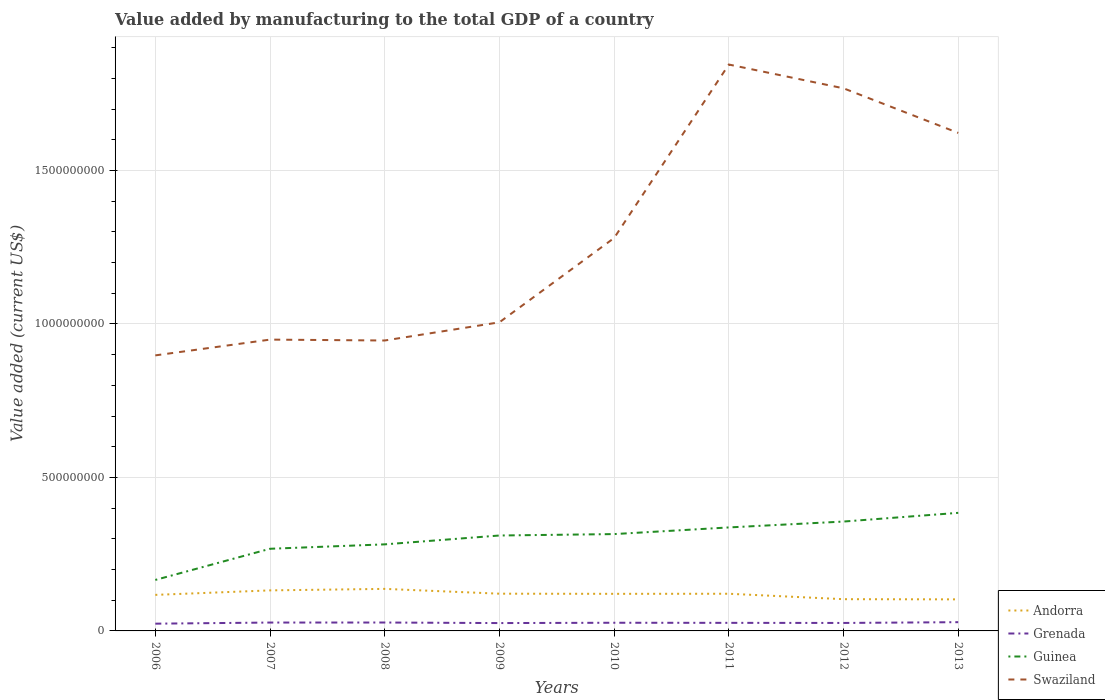Does the line corresponding to Swaziland intersect with the line corresponding to Andorra?
Your answer should be very brief. No. Across all years, what is the maximum value added by manufacturing to the total GDP in Swaziland?
Ensure brevity in your answer.  8.98e+08. What is the total value added by manufacturing to the total GDP in Swaziland in the graph?
Provide a short and direct response. -6.17e+08. What is the difference between the highest and the second highest value added by manufacturing to the total GDP in Grenada?
Ensure brevity in your answer.  4.85e+06. How many years are there in the graph?
Provide a short and direct response. 8. Does the graph contain any zero values?
Provide a succinct answer. No. How many legend labels are there?
Make the answer very short. 4. What is the title of the graph?
Your answer should be compact. Value added by manufacturing to the total GDP of a country. Does "Azerbaijan" appear as one of the legend labels in the graph?
Your answer should be very brief. No. What is the label or title of the X-axis?
Your answer should be compact. Years. What is the label or title of the Y-axis?
Offer a terse response. Value added (current US$). What is the Value added (current US$) in Andorra in 2006?
Make the answer very short. 1.17e+08. What is the Value added (current US$) in Grenada in 2006?
Offer a very short reply. 2.36e+07. What is the Value added (current US$) of Guinea in 2006?
Give a very brief answer. 1.66e+08. What is the Value added (current US$) of Swaziland in 2006?
Ensure brevity in your answer.  8.98e+08. What is the Value added (current US$) of Andorra in 2007?
Ensure brevity in your answer.  1.32e+08. What is the Value added (current US$) of Grenada in 2007?
Provide a short and direct response. 2.73e+07. What is the Value added (current US$) of Guinea in 2007?
Provide a short and direct response. 2.68e+08. What is the Value added (current US$) of Swaziland in 2007?
Provide a succinct answer. 9.49e+08. What is the Value added (current US$) in Andorra in 2008?
Provide a succinct answer. 1.37e+08. What is the Value added (current US$) of Grenada in 2008?
Provide a succinct answer. 2.74e+07. What is the Value added (current US$) in Guinea in 2008?
Offer a very short reply. 2.82e+08. What is the Value added (current US$) in Swaziland in 2008?
Give a very brief answer. 9.46e+08. What is the Value added (current US$) in Andorra in 2009?
Give a very brief answer. 1.21e+08. What is the Value added (current US$) in Grenada in 2009?
Your answer should be very brief. 2.56e+07. What is the Value added (current US$) of Guinea in 2009?
Provide a short and direct response. 3.11e+08. What is the Value added (current US$) in Swaziland in 2009?
Keep it short and to the point. 1.01e+09. What is the Value added (current US$) of Andorra in 2010?
Ensure brevity in your answer.  1.21e+08. What is the Value added (current US$) in Grenada in 2010?
Your answer should be compact. 2.66e+07. What is the Value added (current US$) in Guinea in 2010?
Provide a succinct answer. 3.15e+08. What is the Value added (current US$) of Swaziland in 2010?
Offer a very short reply. 1.28e+09. What is the Value added (current US$) of Andorra in 2011?
Offer a terse response. 1.21e+08. What is the Value added (current US$) of Grenada in 2011?
Offer a terse response. 2.63e+07. What is the Value added (current US$) of Guinea in 2011?
Make the answer very short. 3.37e+08. What is the Value added (current US$) of Swaziland in 2011?
Ensure brevity in your answer.  1.85e+09. What is the Value added (current US$) of Andorra in 2012?
Your answer should be very brief. 1.03e+08. What is the Value added (current US$) in Grenada in 2012?
Provide a short and direct response. 2.60e+07. What is the Value added (current US$) of Guinea in 2012?
Offer a terse response. 3.56e+08. What is the Value added (current US$) in Swaziland in 2012?
Provide a short and direct response. 1.77e+09. What is the Value added (current US$) of Andorra in 2013?
Provide a succinct answer. 1.03e+08. What is the Value added (current US$) of Grenada in 2013?
Provide a short and direct response. 2.85e+07. What is the Value added (current US$) of Guinea in 2013?
Ensure brevity in your answer.  3.85e+08. What is the Value added (current US$) in Swaziland in 2013?
Your answer should be compact. 1.62e+09. Across all years, what is the maximum Value added (current US$) in Andorra?
Your response must be concise. 1.37e+08. Across all years, what is the maximum Value added (current US$) of Grenada?
Ensure brevity in your answer.  2.85e+07. Across all years, what is the maximum Value added (current US$) of Guinea?
Your response must be concise. 3.85e+08. Across all years, what is the maximum Value added (current US$) in Swaziland?
Make the answer very short. 1.85e+09. Across all years, what is the minimum Value added (current US$) in Andorra?
Your answer should be compact. 1.03e+08. Across all years, what is the minimum Value added (current US$) in Grenada?
Your answer should be very brief. 2.36e+07. Across all years, what is the minimum Value added (current US$) in Guinea?
Your response must be concise. 1.66e+08. Across all years, what is the minimum Value added (current US$) of Swaziland?
Keep it short and to the point. 8.98e+08. What is the total Value added (current US$) in Andorra in the graph?
Keep it short and to the point. 9.56e+08. What is the total Value added (current US$) of Grenada in the graph?
Your answer should be compact. 2.11e+08. What is the total Value added (current US$) in Guinea in the graph?
Offer a very short reply. 2.42e+09. What is the total Value added (current US$) of Swaziland in the graph?
Provide a short and direct response. 1.03e+1. What is the difference between the Value added (current US$) of Andorra in 2006 and that in 2007?
Provide a succinct answer. -1.47e+07. What is the difference between the Value added (current US$) in Grenada in 2006 and that in 2007?
Keep it short and to the point. -3.63e+06. What is the difference between the Value added (current US$) in Guinea in 2006 and that in 2007?
Give a very brief answer. -1.02e+08. What is the difference between the Value added (current US$) of Swaziland in 2006 and that in 2007?
Your answer should be compact. -5.14e+07. What is the difference between the Value added (current US$) of Andorra in 2006 and that in 2008?
Give a very brief answer. -1.96e+07. What is the difference between the Value added (current US$) in Grenada in 2006 and that in 2008?
Make the answer very short. -3.73e+06. What is the difference between the Value added (current US$) in Guinea in 2006 and that in 2008?
Your answer should be very brief. -1.16e+08. What is the difference between the Value added (current US$) in Swaziland in 2006 and that in 2008?
Your answer should be compact. -4.85e+07. What is the difference between the Value added (current US$) in Andorra in 2006 and that in 2009?
Offer a very short reply. -3.90e+06. What is the difference between the Value added (current US$) in Grenada in 2006 and that in 2009?
Keep it short and to the point. -1.93e+06. What is the difference between the Value added (current US$) of Guinea in 2006 and that in 2009?
Provide a short and direct response. -1.45e+08. What is the difference between the Value added (current US$) of Swaziland in 2006 and that in 2009?
Ensure brevity in your answer.  -1.08e+08. What is the difference between the Value added (current US$) in Andorra in 2006 and that in 2010?
Your answer should be very brief. -3.42e+06. What is the difference between the Value added (current US$) of Grenada in 2006 and that in 2010?
Offer a terse response. -2.98e+06. What is the difference between the Value added (current US$) in Guinea in 2006 and that in 2010?
Make the answer very short. -1.49e+08. What is the difference between the Value added (current US$) in Swaziland in 2006 and that in 2010?
Make the answer very short. -3.82e+08. What is the difference between the Value added (current US$) in Andorra in 2006 and that in 2011?
Offer a very short reply. -3.69e+06. What is the difference between the Value added (current US$) of Grenada in 2006 and that in 2011?
Ensure brevity in your answer.  -2.66e+06. What is the difference between the Value added (current US$) of Guinea in 2006 and that in 2011?
Your answer should be very brief. -1.71e+08. What is the difference between the Value added (current US$) of Swaziland in 2006 and that in 2011?
Your answer should be compact. -9.47e+08. What is the difference between the Value added (current US$) in Andorra in 2006 and that in 2012?
Provide a succinct answer. 1.40e+07. What is the difference between the Value added (current US$) in Grenada in 2006 and that in 2012?
Offer a very short reply. -2.33e+06. What is the difference between the Value added (current US$) of Guinea in 2006 and that in 2012?
Ensure brevity in your answer.  -1.90e+08. What is the difference between the Value added (current US$) in Swaziland in 2006 and that in 2012?
Make the answer very short. -8.70e+08. What is the difference between the Value added (current US$) of Andorra in 2006 and that in 2013?
Your answer should be very brief. 1.46e+07. What is the difference between the Value added (current US$) in Grenada in 2006 and that in 2013?
Your answer should be compact. -4.85e+06. What is the difference between the Value added (current US$) of Guinea in 2006 and that in 2013?
Make the answer very short. -2.19e+08. What is the difference between the Value added (current US$) of Swaziland in 2006 and that in 2013?
Offer a very short reply. -7.25e+08. What is the difference between the Value added (current US$) in Andorra in 2007 and that in 2008?
Give a very brief answer. -4.90e+06. What is the difference between the Value added (current US$) in Grenada in 2007 and that in 2008?
Offer a very short reply. -1.01e+05. What is the difference between the Value added (current US$) of Guinea in 2007 and that in 2008?
Your response must be concise. -1.44e+07. What is the difference between the Value added (current US$) of Swaziland in 2007 and that in 2008?
Your answer should be very brief. 2.89e+06. What is the difference between the Value added (current US$) of Andorra in 2007 and that in 2009?
Keep it short and to the point. 1.08e+07. What is the difference between the Value added (current US$) of Grenada in 2007 and that in 2009?
Your answer should be very brief. 1.70e+06. What is the difference between the Value added (current US$) of Guinea in 2007 and that in 2009?
Your answer should be compact. -4.32e+07. What is the difference between the Value added (current US$) of Swaziland in 2007 and that in 2009?
Your answer should be compact. -5.64e+07. What is the difference between the Value added (current US$) of Andorra in 2007 and that in 2010?
Give a very brief answer. 1.12e+07. What is the difference between the Value added (current US$) of Grenada in 2007 and that in 2010?
Your answer should be compact. 6.45e+05. What is the difference between the Value added (current US$) in Guinea in 2007 and that in 2010?
Make the answer very short. -4.78e+07. What is the difference between the Value added (current US$) of Swaziland in 2007 and that in 2010?
Your answer should be very brief. -3.31e+08. What is the difference between the Value added (current US$) of Andorra in 2007 and that in 2011?
Offer a terse response. 1.10e+07. What is the difference between the Value added (current US$) of Grenada in 2007 and that in 2011?
Ensure brevity in your answer.  9.70e+05. What is the difference between the Value added (current US$) of Guinea in 2007 and that in 2011?
Ensure brevity in your answer.  -6.95e+07. What is the difference between the Value added (current US$) of Swaziland in 2007 and that in 2011?
Your answer should be compact. -8.96e+08. What is the difference between the Value added (current US$) of Andorra in 2007 and that in 2012?
Offer a very short reply. 2.87e+07. What is the difference between the Value added (current US$) of Grenada in 2007 and that in 2012?
Your answer should be very brief. 1.30e+06. What is the difference between the Value added (current US$) in Guinea in 2007 and that in 2012?
Keep it short and to the point. -8.87e+07. What is the difference between the Value added (current US$) of Swaziland in 2007 and that in 2012?
Keep it short and to the point. -8.19e+08. What is the difference between the Value added (current US$) of Andorra in 2007 and that in 2013?
Provide a succinct answer. 2.93e+07. What is the difference between the Value added (current US$) of Grenada in 2007 and that in 2013?
Your answer should be very brief. -1.22e+06. What is the difference between the Value added (current US$) in Guinea in 2007 and that in 2013?
Provide a short and direct response. -1.17e+08. What is the difference between the Value added (current US$) of Swaziland in 2007 and that in 2013?
Give a very brief answer. -6.73e+08. What is the difference between the Value added (current US$) of Andorra in 2008 and that in 2009?
Offer a terse response. 1.57e+07. What is the difference between the Value added (current US$) of Grenada in 2008 and that in 2009?
Offer a very short reply. 1.80e+06. What is the difference between the Value added (current US$) of Guinea in 2008 and that in 2009?
Your answer should be compact. -2.89e+07. What is the difference between the Value added (current US$) of Swaziland in 2008 and that in 2009?
Your answer should be compact. -5.93e+07. What is the difference between the Value added (current US$) of Andorra in 2008 and that in 2010?
Your answer should be compact. 1.61e+07. What is the difference between the Value added (current US$) in Grenada in 2008 and that in 2010?
Ensure brevity in your answer.  7.47e+05. What is the difference between the Value added (current US$) of Guinea in 2008 and that in 2010?
Make the answer very short. -3.35e+07. What is the difference between the Value added (current US$) in Swaziland in 2008 and that in 2010?
Offer a terse response. -3.34e+08. What is the difference between the Value added (current US$) in Andorra in 2008 and that in 2011?
Offer a very short reply. 1.59e+07. What is the difference between the Value added (current US$) in Grenada in 2008 and that in 2011?
Provide a short and direct response. 1.07e+06. What is the difference between the Value added (current US$) of Guinea in 2008 and that in 2011?
Offer a terse response. -5.51e+07. What is the difference between the Value added (current US$) of Swaziland in 2008 and that in 2011?
Give a very brief answer. -8.99e+08. What is the difference between the Value added (current US$) in Andorra in 2008 and that in 2012?
Offer a terse response. 3.36e+07. What is the difference between the Value added (current US$) of Grenada in 2008 and that in 2012?
Make the answer very short. 1.40e+06. What is the difference between the Value added (current US$) in Guinea in 2008 and that in 2012?
Offer a very short reply. -7.43e+07. What is the difference between the Value added (current US$) of Swaziland in 2008 and that in 2012?
Give a very brief answer. -8.22e+08. What is the difference between the Value added (current US$) of Andorra in 2008 and that in 2013?
Ensure brevity in your answer.  3.42e+07. What is the difference between the Value added (current US$) of Grenada in 2008 and that in 2013?
Offer a very short reply. -1.12e+06. What is the difference between the Value added (current US$) in Guinea in 2008 and that in 2013?
Provide a short and direct response. -1.03e+08. What is the difference between the Value added (current US$) in Swaziland in 2008 and that in 2013?
Make the answer very short. -6.76e+08. What is the difference between the Value added (current US$) in Andorra in 2009 and that in 2010?
Make the answer very short. 4.77e+05. What is the difference between the Value added (current US$) of Grenada in 2009 and that in 2010?
Offer a terse response. -1.05e+06. What is the difference between the Value added (current US$) in Guinea in 2009 and that in 2010?
Offer a very short reply. -4.61e+06. What is the difference between the Value added (current US$) of Swaziland in 2009 and that in 2010?
Make the answer very short. -2.75e+08. What is the difference between the Value added (current US$) in Andorra in 2009 and that in 2011?
Ensure brevity in your answer.  2.10e+05. What is the difference between the Value added (current US$) in Grenada in 2009 and that in 2011?
Offer a terse response. -7.28e+05. What is the difference between the Value added (current US$) of Guinea in 2009 and that in 2011?
Make the answer very short. -2.63e+07. What is the difference between the Value added (current US$) of Swaziland in 2009 and that in 2011?
Offer a terse response. -8.40e+08. What is the difference between the Value added (current US$) in Andorra in 2009 and that in 2012?
Give a very brief answer. 1.79e+07. What is the difference between the Value added (current US$) in Grenada in 2009 and that in 2012?
Your response must be concise. -4.00e+05. What is the difference between the Value added (current US$) of Guinea in 2009 and that in 2012?
Ensure brevity in your answer.  -4.55e+07. What is the difference between the Value added (current US$) of Swaziland in 2009 and that in 2012?
Your answer should be very brief. -7.62e+08. What is the difference between the Value added (current US$) in Andorra in 2009 and that in 2013?
Your response must be concise. 1.85e+07. What is the difference between the Value added (current US$) of Grenada in 2009 and that in 2013?
Ensure brevity in your answer.  -2.92e+06. What is the difference between the Value added (current US$) of Guinea in 2009 and that in 2013?
Give a very brief answer. -7.38e+07. What is the difference between the Value added (current US$) of Swaziland in 2009 and that in 2013?
Your answer should be very brief. -6.17e+08. What is the difference between the Value added (current US$) of Andorra in 2010 and that in 2011?
Offer a very short reply. -2.67e+05. What is the difference between the Value added (current US$) of Grenada in 2010 and that in 2011?
Make the answer very short. 3.25e+05. What is the difference between the Value added (current US$) of Guinea in 2010 and that in 2011?
Give a very brief answer. -2.17e+07. What is the difference between the Value added (current US$) of Swaziland in 2010 and that in 2011?
Provide a short and direct response. -5.65e+08. What is the difference between the Value added (current US$) of Andorra in 2010 and that in 2012?
Your response must be concise. 1.74e+07. What is the difference between the Value added (current US$) in Grenada in 2010 and that in 2012?
Provide a short and direct response. 6.53e+05. What is the difference between the Value added (current US$) of Guinea in 2010 and that in 2012?
Your answer should be very brief. -4.08e+07. What is the difference between the Value added (current US$) of Swaziland in 2010 and that in 2012?
Your answer should be compact. -4.88e+08. What is the difference between the Value added (current US$) in Andorra in 2010 and that in 2013?
Offer a very short reply. 1.80e+07. What is the difference between the Value added (current US$) of Grenada in 2010 and that in 2013?
Your response must be concise. -1.86e+06. What is the difference between the Value added (current US$) of Guinea in 2010 and that in 2013?
Offer a very short reply. -6.92e+07. What is the difference between the Value added (current US$) of Swaziland in 2010 and that in 2013?
Your answer should be compact. -3.42e+08. What is the difference between the Value added (current US$) in Andorra in 2011 and that in 2012?
Offer a terse response. 1.77e+07. What is the difference between the Value added (current US$) of Grenada in 2011 and that in 2012?
Your answer should be compact. 3.28e+05. What is the difference between the Value added (current US$) in Guinea in 2011 and that in 2012?
Make the answer very short. -1.92e+07. What is the difference between the Value added (current US$) of Swaziland in 2011 and that in 2012?
Give a very brief answer. 7.75e+07. What is the difference between the Value added (current US$) in Andorra in 2011 and that in 2013?
Offer a very short reply. 1.83e+07. What is the difference between the Value added (current US$) of Grenada in 2011 and that in 2013?
Give a very brief answer. -2.19e+06. What is the difference between the Value added (current US$) in Guinea in 2011 and that in 2013?
Make the answer very short. -4.75e+07. What is the difference between the Value added (current US$) of Swaziland in 2011 and that in 2013?
Provide a succinct answer. 2.23e+08. What is the difference between the Value added (current US$) of Andorra in 2012 and that in 2013?
Provide a succinct answer. 5.73e+05. What is the difference between the Value added (current US$) of Grenada in 2012 and that in 2013?
Your answer should be compact. -2.52e+06. What is the difference between the Value added (current US$) of Guinea in 2012 and that in 2013?
Offer a very short reply. -2.83e+07. What is the difference between the Value added (current US$) of Swaziland in 2012 and that in 2013?
Your answer should be very brief. 1.45e+08. What is the difference between the Value added (current US$) of Andorra in 2006 and the Value added (current US$) of Grenada in 2007?
Offer a terse response. 9.01e+07. What is the difference between the Value added (current US$) of Andorra in 2006 and the Value added (current US$) of Guinea in 2007?
Your response must be concise. -1.50e+08. What is the difference between the Value added (current US$) in Andorra in 2006 and the Value added (current US$) in Swaziland in 2007?
Your response must be concise. -8.32e+08. What is the difference between the Value added (current US$) in Grenada in 2006 and the Value added (current US$) in Guinea in 2007?
Your answer should be very brief. -2.44e+08. What is the difference between the Value added (current US$) in Grenada in 2006 and the Value added (current US$) in Swaziland in 2007?
Ensure brevity in your answer.  -9.25e+08. What is the difference between the Value added (current US$) of Guinea in 2006 and the Value added (current US$) of Swaziland in 2007?
Offer a terse response. -7.83e+08. What is the difference between the Value added (current US$) of Andorra in 2006 and the Value added (current US$) of Grenada in 2008?
Your answer should be compact. 9.00e+07. What is the difference between the Value added (current US$) in Andorra in 2006 and the Value added (current US$) in Guinea in 2008?
Make the answer very short. -1.65e+08. What is the difference between the Value added (current US$) of Andorra in 2006 and the Value added (current US$) of Swaziland in 2008?
Offer a terse response. -8.29e+08. What is the difference between the Value added (current US$) of Grenada in 2006 and the Value added (current US$) of Guinea in 2008?
Your response must be concise. -2.58e+08. What is the difference between the Value added (current US$) in Grenada in 2006 and the Value added (current US$) in Swaziland in 2008?
Keep it short and to the point. -9.22e+08. What is the difference between the Value added (current US$) in Guinea in 2006 and the Value added (current US$) in Swaziland in 2008?
Keep it short and to the point. -7.80e+08. What is the difference between the Value added (current US$) of Andorra in 2006 and the Value added (current US$) of Grenada in 2009?
Your answer should be compact. 9.18e+07. What is the difference between the Value added (current US$) in Andorra in 2006 and the Value added (current US$) in Guinea in 2009?
Offer a terse response. -1.93e+08. What is the difference between the Value added (current US$) of Andorra in 2006 and the Value added (current US$) of Swaziland in 2009?
Provide a short and direct response. -8.88e+08. What is the difference between the Value added (current US$) of Grenada in 2006 and the Value added (current US$) of Guinea in 2009?
Ensure brevity in your answer.  -2.87e+08. What is the difference between the Value added (current US$) in Grenada in 2006 and the Value added (current US$) in Swaziland in 2009?
Ensure brevity in your answer.  -9.82e+08. What is the difference between the Value added (current US$) in Guinea in 2006 and the Value added (current US$) in Swaziland in 2009?
Your response must be concise. -8.39e+08. What is the difference between the Value added (current US$) in Andorra in 2006 and the Value added (current US$) in Grenada in 2010?
Offer a terse response. 9.08e+07. What is the difference between the Value added (current US$) of Andorra in 2006 and the Value added (current US$) of Guinea in 2010?
Your answer should be very brief. -1.98e+08. What is the difference between the Value added (current US$) of Andorra in 2006 and the Value added (current US$) of Swaziland in 2010?
Make the answer very short. -1.16e+09. What is the difference between the Value added (current US$) in Grenada in 2006 and the Value added (current US$) in Guinea in 2010?
Make the answer very short. -2.92e+08. What is the difference between the Value added (current US$) of Grenada in 2006 and the Value added (current US$) of Swaziland in 2010?
Offer a terse response. -1.26e+09. What is the difference between the Value added (current US$) of Guinea in 2006 and the Value added (current US$) of Swaziland in 2010?
Your answer should be compact. -1.11e+09. What is the difference between the Value added (current US$) of Andorra in 2006 and the Value added (current US$) of Grenada in 2011?
Provide a short and direct response. 9.11e+07. What is the difference between the Value added (current US$) in Andorra in 2006 and the Value added (current US$) in Guinea in 2011?
Give a very brief answer. -2.20e+08. What is the difference between the Value added (current US$) in Andorra in 2006 and the Value added (current US$) in Swaziland in 2011?
Your answer should be very brief. -1.73e+09. What is the difference between the Value added (current US$) of Grenada in 2006 and the Value added (current US$) of Guinea in 2011?
Give a very brief answer. -3.13e+08. What is the difference between the Value added (current US$) in Grenada in 2006 and the Value added (current US$) in Swaziland in 2011?
Your answer should be very brief. -1.82e+09. What is the difference between the Value added (current US$) in Guinea in 2006 and the Value added (current US$) in Swaziland in 2011?
Your answer should be very brief. -1.68e+09. What is the difference between the Value added (current US$) of Andorra in 2006 and the Value added (current US$) of Grenada in 2012?
Give a very brief answer. 9.14e+07. What is the difference between the Value added (current US$) in Andorra in 2006 and the Value added (current US$) in Guinea in 2012?
Your answer should be very brief. -2.39e+08. What is the difference between the Value added (current US$) in Andorra in 2006 and the Value added (current US$) in Swaziland in 2012?
Provide a short and direct response. -1.65e+09. What is the difference between the Value added (current US$) in Grenada in 2006 and the Value added (current US$) in Guinea in 2012?
Make the answer very short. -3.33e+08. What is the difference between the Value added (current US$) of Grenada in 2006 and the Value added (current US$) of Swaziland in 2012?
Your answer should be compact. -1.74e+09. What is the difference between the Value added (current US$) of Guinea in 2006 and the Value added (current US$) of Swaziland in 2012?
Ensure brevity in your answer.  -1.60e+09. What is the difference between the Value added (current US$) of Andorra in 2006 and the Value added (current US$) of Grenada in 2013?
Make the answer very short. 8.89e+07. What is the difference between the Value added (current US$) of Andorra in 2006 and the Value added (current US$) of Guinea in 2013?
Ensure brevity in your answer.  -2.67e+08. What is the difference between the Value added (current US$) of Andorra in 2006 and the Value added (current US$) of Swaziland in 2013?
Your response must be concise. -1.50e+09. What is the difference between the Value added (current US$) of Grenada in 2006 and the Value added (current US$) of Guinea in 2013?
Your answer should be very brief. -3.61e+08. What is the difference between the Value added (current US$) of Grenada in 2006 and the Value added (current US$) of Swaziland in 2013?
Your answer should be very brief. -1.60e+09. What is the difference between the Value added (current US$) of Guinea in 2006 and the Value added (current US$) of Swaziland in 2013?
Keep it short and to the point. -1.46e+09. What is the difference between the Value added (current US$) in Andorra in 2007 and the Value added (current US$) in Grenada in 2008?
Ensure brevity in your answer.  1.05e+08. What is the difference between the Value added (current US$) of Andorra in 2007 and the Value added (current US$) of Guinea in 2008?
Offer a very short reply. -1.50e+08. What is the difference between the Value added (current US$) in Andorra in 2007 and the Value added (current US$) in Swaziland in 2008?
Offer a terse response. -8.14e+08. What is the difference between the Value added (current US$) in Grenada in 2007 and the Value added (current US$) in Guinea in 2008?
Your answer should be very brief. -2.55e+08. What is the difference between the Value added (current US$) in Grenada in 2007 and the Value added (current US$) in Swaziland in 2008?
Offer a terse response. -9.19e+08. What is the difference between the Value added (current US$) of Guinea in 2007 and the Value added (current US$) of Swaziland in 2008?
Provide a succinct answer. -6.78e+08. What is the difference between the Value added (current US$) in Andorra in 2007 and the Value added (current US$) in Grenada in 2009?
Offer a terse response. 1.06e+08. What is the difference between the Value added (current US$) of Andorra in 2007 and the Value added (current US$) of Guinea in 2009?
Offer a terse response. -1.79e+08. What is the difference between the Value added (current US$) of Andorra in 2007 and the Value added (current US$) of Swaziland in 2009?
Offer a terse response. -8.73e+08. What is the difference between the Value added (current US$) of Grenada in 2007 and the Value added (current US$) of Guinea in 2009?
Your answer should be compact. -2.84e+08. What is the difference between the Value added (current US$) in Grenada in 2007 and the Value added (current US$) in Swaziland in 2009?
Give a very brief answer. -9.78e+08. What is the difference between the Value added (current US$) in Guinea in 2007 and the Value added (current US$) in Swaziland in 2009?
Keep it short and to the point. -7.38e+08. What is the difference between the Value added (current US$) in Andorra in 2007 and the Value added (current US$) in Grenada in 2010?
Offer a terse response. 1.05e+08. What is the difference between the Value added (current US$) in Andorra in 2007 and the Value added (current US$) in Guinea in 2010?
Your response must be concise. -1.83e+08. What is the difference between the Value added (current US$) of Andorra in 2007 and the Value added (current US$) of Swaziland in 2010?
Your answer should be compact. -1.15e+09. What is the difference between the Value added (current US$) of Grenada in 2007 and the Value added (current US$) of Guinea in 2010?
Your answer should be very brief. -2.88e+08. What is the difference between the Value added (current US$) of Grenada in 2007 and the Value added (current US$) of Swaziland in 2010?
Make the answer very short. -1.25e+09. What is the difference between the Value added (current US$) in Guinea in 2007 and the Value added (current US$) in Swaziland in 2010?
Your answer should be very brief. -1.01e+09. What is the difference between the Value added (current US$) in Andorra in 2007 and the Value added (current US$) in Grenada in 2011?
Your response must be concise. 1.06e+08. What is the difference between the Value added (current US$) in Andorra in 2007 and the Value added (current US$) in Guinea in 2011?
Offer a terse response. -2.05e+08. What is the difference between the Value added (current US$) of Andorra in 2007 and the Value added (current US$) of Swaziland in 2011?
Your answer should be compact. -1.71e+09. What is the difference between the Value added (current US$) in Grenada in 2007 and the Value added (current US$) in Guinea in 2011?
Give a very brief answer. -3.10e+08. What is the difference between the Value added (current US$) in Grenada in 2007 and the Value added (current US$) in Swaziland in 2011?
Ensure brevity in your answer.  -1.82e+09. What is the difference between the Value added (current US$) in Guinea in 2007 and the Value added (current US$) in Swaziland in 2011?
Provide a succinct answer. -1.58e+09. What is the difference between the Value added (current US$) of Andorra in 2007 and the Value added (current US$) of Grenada in 2012?
Keep it short and to the point. 1.06e+08. What is the difference between the Value added (current US$) in Andorra in 2007 and the Value added (current US$) in Guinea in 2012?
Give a very brief answer. -2.24e+08. What is the difference between the Value added (current US$) in Andorra in 2007 and the Value added (current US$) in Swaziland in 2012?
Offer a terse response. -1.64e+09. What is the difference between the Value added (current US$) of Grenada in 2007 and the Value added (current US$) of Guinea in 2012?
Provide a succinct answer. -3.29e+08. What is the difference between the Value added (current US$) of Grenada in 2007 and the Value added (current US$) of Swaziland in 2012?
Ensure brevity in your answer.  -1.74e+09. What is the difference between the Value added (current US$) of Guinea in 2007 and the Value added (current US$) of Swaziland in 2012?
Provide a succinct answer. -1.50e+09. What is the difference between the Value added (current US$) of Andorra in 2007 and the Value added (current US$) of Grenada in 2013?
Give a very brief answer. 1.04e+08. What is the difference between the Value added (current US$) in Andorra in 2007 and the Value added (current US$) in Guinea in 2013?
Your response must be concise. -2.53e+08. What is the difference between the Value added (current US$) of Andorra in 2007 and the Value added (current US$) of Swaziland in 2013?
Your response must be concise. -1.49e+09. What is the difference between the Value added (current US$) of Grenada in 2007 and the Value added (current US$) of Guinea in 2013?
Make the answer very short. -3.57e+08. What is the difference between the Value added (current US$) of Grenada in 2007 and the Value added (current US$) of Swaziland in 2013?
Provide a short and direct response. -1.60e+09. What is the difference between the Value added (current US$) in Guinea in 2007 and the Value added (current US$) in Swaziland in 2013?
Offer a terse response. -1.35e+09. What is the difference between the Value added (current US$) in Andorra in 2008 and the Value added (current US$) in Grenada in 2009?
Make the answer very short. 1.11e+08. What is the difference between the Value added (current US$) in Andorra in 2008 and the Value added (current US$) in Guinea in 2009?
Your answer should be very brief. -1.74e+08. What is the difference between the Value added (current US$) in Andorra in 2008 and the Value added (current US$) in Swaziland in 2009?
Provide a succinct answer. -8.68e+08. What is the difference between the Value added (current US$) in Grenada in 2008 and the Value added (current US$) in Guinea in 2009?
Give a very brief answer. -2.83e+08. What is the difference between the Value added (current US$) in Grenada in 2008 and the Value added (current US$) in Swaziland in 2009?
Give a very brief answer. -9.78e+08. What is the difference between the Value added (current US$) in Guinea in 2008 and the Value added (current US$) in Swaziland in 2009?
Offer a very short reply. -7.23e+08. What is the difference between the Value added (current US$) in Andorra in 2008 and the Value added (current US$) in Grenada in 2010?
Provide a short and direct response. 1.10e+08. What is the difference between the Value added (current US$) in Andorra in 2008 and the Value added (current US$) in Guinea in 2010?
Provide a short and direct response. -1.79e+08. What is the difference between the Value added (current US$) of Andorra in 2008 and the Value added (current US$) of Swaziland in 2010?
Keep it short and to the point. -1.14e+09. What is the difference between the Value added (current US$) of Grenada in 2008 and the Value added (current US$) of Guinea in 2010?
Ensure brevity in your answer.  -2.88e+08. What is the difference between the Value added (current US$) in Grenada in 2008 and the Value added (current US$) in Swaziland in 2010?
Offer a terse response. -1.25e+09. What is the difference between the Value added (current US$) of Guinea in 2008 and the Value added (current US$) of Swaziland in 2010?
Offer a terse response. -9.98e+08. What is the difference between the Value added (current US$) of Andorra in 2008 and the Value added (current US$) of Grenada in 2011?
Offer a terse response. 1.11e+08. What is the difference between the Value added (current US$) in Andorra in 2008 and the Value added (current US$) in Guinea in 2011?
Offer a terse response. -2.00e+08. What is the difference between the Value added (current US$) of Andorra in 2008 and the Value added (current US$) of Swaziland in 2011?
Ensure brevity in your answer.  -1.71e+09. What is the difference between the Value added (current US$) in Grenada in 2008 and the Value added (current US$) in Guinea in 2011?
Your answer should be compact. -3.10e+08. What is the difference between the Value added (current US$) of Grenada in 2008 and the Value added (current US$) of Swaziland in 2011?
Provide a succinct answer. -1.82e+09. What is the difference between the Value added (current US$) of Guinea in 2008 and the Value added (current US$) of Swaziland in 2011?
Make the answer very short. -1.56e+09. What is the difference between the Value added (current US$) in Andorra in 2008 and the Value added (current US$) in Grenada in 2012?
Your response must be concise. 1.11e+08. What is the difference between the Value added (current US$) in Andorra in 2008 and the Value added (current US$) in Guinea in 2012?
Your answer should be compact. -2.19e+08. What is the difference between the Value added (current US$) in Andorra in 2008 and the Value added (current US$) in Swaziland in 2012?
Ensure brevity in your answer.  -1.63e+09. What is the difference between the Value added (current US$) in Grenada in 2008 and the Value added (current US$) in Guinea in 2012?
Keep it short and to the point. -3.29e+08. What is the difference between the Value added (current US$) of Grenada in 2008 and the Value added (current US$) of Swaziland in 2012?
Your response must be concise. -1.74e+09. What is the difference between the Value added (current US$) in Guinea in 2008 and the Value added (current US$) in Swaziland in 2012?
Your answer should be very brief. -1.49e+09. What is the difference between the Value added (current US$) in Andorra in 2008 and the Value added (current US$) in Grenada in 2013?
Give a very brief answer. 1.08e+08. What is the difference between the Value added (current US$) in Andorra in 2008 and the Value added (current US$) in Guinea in 2013?
Your response must be concise. -2.48e+08. What is the difference between the Value added (current US$) in Andorra in 2008 and the Value added (current US$) in Swaziland in 2013?
Make the answer very short. -1.49e+09. What is the difference between the Value added (current US$) of Grenada in 2008 and the Value added (current US$) of Guinea in 2013?
Ensure brevity in your answer.  -3.57e+08. What is the difference between the Value added (current US$) in Grenada in 2008 and the Value added (current US$) in Swaziland in 2013?
Your answer should be compact. -1.60e+09. What is the difference between the Value added (current US$) in Guinea in 2008 and the Value added (current US$) in Swaziland in 2013?
Offer a terse response. -1.34e+09. What is the difference between the Value added (current US$) in Andorra in 2009 and the Value added (current US$) in Grenada in 2010?
Ensure brevity in your answer.  9.47e+07. What is the difference between the Value added (current US$) in Andorra in 2009 and the Value added (current US$) in Guinea in 2010?
Provide a short and direct response. -1.94e+08. What is the difference between the Value added (current US$) of Andorra in 2009 and the Value added (current US$) of Swaziland in 2010?
Make the answer very short. -1.16e+09. What is the difference between the Value added (current US$) in Grenada in 2009 and the Value added (current US$) in Guinea in 2010?
Your answer should be compact. -2.90e+08. What is the difference between the Value added (current US$) in Grenada in 2009 and the Value added (current US$) in Swaziland in 2010?
Offer a terse response. -1.25e+09. What is the difference between the Value added (current US$) of Guinea in 2009 and the Value added (current US$) of Swaziland in 2010?
Offer a very short reply. -9.69e+08. What is the difference between the Value added (current US$) in Andorra in 2009 and the Value added (current US$) in Grenada in 2011?
Offer a very short reply. 9.50e+07. What is the difference between the Value added (current US$) of Andorra in 2009 and the Value added (current US$) of Guinea in 2011?
Keep it short and to the point. -2.16e+08. What is the difference between the Value added (current US$) in Andorra in 2009 and the Value added (current US$) in Swaziland in 2011?
Make the answer very short. -1.72e+09. What is the difference between the Value added (current US$) of Grenada in 2009 and the Value added (current US$) of Guinea in 2011?
Give a very brief answer. -3.12e+08. What is the difference between the Value added (current US$) of Grenada in 2009 and the Value added (current US$) of Swaziland in 2011?
Provide a short and direct response. -1.82e+09. What is the difference between the Value added (current US$) in Guinea in 2009 and the Value added (current US$) in Swaziland in 2011?
Give a very brief answer. -1.53e+09. What is the difference between the Value added (current US$) in Andorra in 2009 and the Value added (current US$) in Grenada in 2012?
Your response must be concise. 9.53e+07. What is the difference between the Value added (current US$) of Andorra in 2009 and the Value added (current US$) of Guinea in 2012?
Offer a terse response. -2.35e+08. What is the difference between the Value added (current US$) of Andorra in 2009 and the Value added (current US$) of Swaziland in 2012?
Ensure brevity in your answer.  -1.65e+09. What is the difference between the Value added (current US$) of Grenada in 2009 and the Value added (current US$) of Guinea in 2012?
Provide a short and direct response. -3.31e+08. What is the difference between the Value added (current US$) in Grenada in 2009 and the Value added (current US$) in Swaziland in 2012?
Provide a short and direct response. -1.74e+09. What is the difference between the Value added (current US$) in Guinea in 2009 and the Value added (current US$) in Swaziland in 2012?
Keep it short and to the point. -1.46e+09. What is the difference between the Value added (current US$) in Andorra in 2009 and the Value added (current US$) in Grenada in 2013?
Your answer should be very brief. 9.28e+07. What is the difference between the Value added (current US$) in Andorra in 2009 and the Value added (current US$) in Guinea in 2013?
Your response must be concise. -2.63e+08. What is the difference between the Value added (current US$) in Andorra in 2009 and the Value added (current US$) in Swaziland in 2013?
Make the answer very short. -1.50e+09. What is the difference between the Value added (current US$) of Grenada in 2009 and the Value added (current US$) of Guinea in 2013?
Give a very brief answer. -3.59e+08. What is the difference between the Value added (current US$) in Grenada in 2009 and the Value added (current US$) in Swaziland in 2013?
Give a very brief answer. -1.60e+09. What is the difference between the Value added (current US$) of Guinea in 2009 and the Value added (current US$) of Swaziland in 2013?
Provide a short and direct response. -1.31e+09. What is the difference between the Value added (current US$) of Andorra in 2010 and the Value added (current US$) of Grenada in 2011?
Provide a succinct answer. 9.45e+07. What is the difference between the Value added (current US$) of Andorra in 2010 and the Value added (current US$) of Guinea in 2011?
Give a very brief answer. -2.16e+08. What is the difference between the Value added (current US$) of Andorra in 2010 and the Value added (current US$) of Swaziland in 2011?
Provide a succinct answer. -1.72e+09. What is the difference between the Value added (current US$) of Grenada in 2010 and the Value added (current US$) of Guinea in 2011?
Give a very brief answer. -3.11e+08. What is the difference between the Value added (current US$) of Grenada in 2010 and the Value added (current US$) of Swaziland in 2011?
Your response must be concise. -1.82e+09. What is the difference between the Value added (current US$) of Guinea in 2010 and the Value added (current US$) of Swaziland in 2011?
Your answer should be compact. -1.53e+09. What is the difference between the Value added (current US$) of Andorra in 2010 and the Value added (current US$) of Grenada in 2012?
Your response must be concise. 9.49e+07. What is the difference between the Value added (current US$) of Andorra in 2010 and the Value added (current US$) of Guinea in 2012?
Provide a short and direct response. -2.35e+08. What is the difference between the Value added (current US$) in Andorra in 2010 and the Value added (current US$) in Swaziland in 2012?
Provide a succinct answer. -1.65e+09. What is the difference between the Value added (current US$) in Grenada in 2010 and the Value added (current US$) in Guinea in 2012?
Provide a succinct answer. -3.30e+08. What is the difference between the Value added (current US$) of Grenada in 2010 and the Value added (current US$) of Swaziland in 2012?
Provide a short and direct response. -1.74e+09. What is the difference between the Value added (current US$) of Guinea in 2010 and the Value added (current US$) of Swaziland in 2012?
Your answer should be very brief. -1.45e+09. What is the difference between the Value added (current US$) in Andorra in 2010 and the Value added (current US$) in Grenada in 2013?
Provide a short and direct response. 9.23e+07. What is the difference between the Value added (current US$) of Andorra in 2010 and the Value added (current US$) of Guinea in 2013?
Offer a very short reply. -2.64e+08. What is the difference between the Value added (current US$) in Andorra in 2010 and the Value added (current US$) in Swaziland in 2013?
Keep it short and to the point. -1.50e+09. What is the difference between the Value added (current US$) of Grenada in 2010 and the Value added (current US$) of Guinea in 2013?
Make the answer very short. -3.58e+08. What is the difference between the Value added (current US$) in Grenada in 2010 and the Value added (current US$) in Swaziland in 2013?
Keep it short and to the point. -1.60e+09. What is the difference between the Value added (current US$) of Guinea in 2010 and the Value added (current US$) of Swaziland in 2013?
Give a very brief answer. -1.31e+09. What is the difference between the Value added (current US$) in Andorra in 2011 and the Value added (current US$) in Grenada in 2012?
Your answer should be compact. 9.51e+07. What is the difference between the Value added (current US$) in Andorra in 2011 and the Value added (current US$) in Guinea in 2012?
Offer a terse response. -2.35e+08. What is the difference between the Value added (current US$) in Andorra in 2011 and the Value added (current US$) in Swaziland in 2012?
Give a very brief answer. -1.65e+09. What is the difference between the Value added (current US$) in Grenada in 2011 and the Value added (current US$) in Guinea in 2012?
Your answer should be very brief. -3.30e+08. What is the difference between the Value added (current US$) in Grenada in 2011 and the Value added (current US$) in Swaziland in 2012?
Make the answer very short. -1.74e+09. What is the difference between the Value added (current US$) of Guinea in 2011 and the Value added (current US$) of Swaziland in 2012?
Offer a terse response. -1.43e+09. What is the difference between the Value added (current US$) of Andorra in 2011 and the Value added (current US$) of Grenada in 2013?
Your answer should be compact. 9.26e+07. What is the difference between the Value added (current US$) of Andorra in 2011 and the Value added (current US$) of Guinea in 2013?
Make the answer very short. -2.64e+08. What is the difference between the Value added (current US$) in Andorra in 2011 and the Value added (current US$) in Swaziland in 2013?
Provide a succinct answer. -1.50e+09. What is the difference between the Value added (current US$) of Grenada in 2011 and the Value added (current US$) of Guinea in 2013?
Provide a succinct answer. -3.58e+08. What is the difference between the Value added (current US$) in Grenada in 2011 and the Value added (current US$) in Swaziland in 2013?
Offer a terse response. -1.60e+09. What is the difference between the Value added (current US$) of Guinea in 2011 and the Value added (current US$) of Swaziland in 2013?
Your response must be concise. -1.29e+09. What is the difference between the Value added (current US$) in Andorra in 2012 and the Value added (current US$) in Grenada in 2013?
Your answer should be compact. 7.49e+07. What is the difference between the Value added (current US$) in Andorra in 2012 and the Value added (current US$) in Guinea in 2013?
Keep it short and to the point. -2.81e+08. What is the difference between the Value added (current US$) in Andorra in 2012 and the Value added (current US$) in Swaziland in 2013?
Ensure brevity in your answer.  -1.52e+09. What is the difference between the Value added (current US$) in Grenada in 2012 and the Value added (current US$) in Guinea in 2013?
Provide a succinct answer. -3.59e+08. What is the difference between the Value added (current US$) in Grenada in 2012 and the Value added (current US$) in Swaziland in 2013?
Your answer should be compact. -1.60e+09. What is the difference between the Value added (current US$) in Guinea in 2012 and the Value added (current US$) in Swaziland in 2013?
Your answer should be very brief. -1.27e+09. What is the average Value added (current US$) of Andorra per year?
Offer a very short reply. 1.19e+08. What is the average Value added (current US$) of Grenada per year?
Make the answer very short. 2.64e+07. What is the average Value added (current US$) of Guinea per year?
Ensure brevity in your answer.  3.03e+08. What is the average Value added (current US$) of Swaziland per year?
Your answer should be compact. 1.29e+09. In the year 2006, what is the difference between the Value added (current US$) of Andorra and Value added (current US$) of Grenada?
Offer a terse response. 9.38e+07. In the year 2006, what is the difference between the Value added (current US$) of Andorra and Value added (current US$) of Guinea?
Provide a short and direct response. -4.87e+07. In the year 2006, what is the difference between the Value added (current US$) in Andorra and Value added (current US$) in Swaziland?
Provide a succinct answer. -7.80e+08. In the year 2006, what is the difference between the Value added (current US$) of Grenada and Value added (current US$) of Guinea?
Your answer should be compact. -1.42e+08. In the year 2006, what is the difference between the Value added (current US$) of Grenada and Value added (current US$) of Swaziland?
Your response must be concise. -8.74e+08. In the year 2006, what is the difference between the Value added (current US$) in Guinea and Value added (current US$) in Swaziland?
Offer a very short reply. -7.32e+08. In the year 2007, what is the difference between the Value added (current US$) of Andorra and Value added (current US$) of Grenada?
Give a very brief answer. 1.05e+08. In the year 2007, what is the difference between the Value added (current US$) of Andorra and Value added (current US$) of Guinea?
Keep it short and to the point. -1.36e+08. In the year 2007, what is the difference between the Value added (current US$) in Andorra and Value added (current US$) in Swaziland?
Offer a terse response. -8.17e+08. In the year 2007, what is the difference between the Value added (current US$) in Grenada and Value added (current US$) in Guinea?
Make the answer very short. -2.40e+08. In the year 2007, what is the difference between the Value added (current US$) in Grenada and Value added (current US$) in Swaziland?
Offer a terse response. -9.22e+08. In the year 2007, what is the difference between the Value added (current US$) of Guinea and Value added (current US$) of Swaziland?
Make the answer very short. -6.81e+08. In the year 2008, what is the difference between the Value added (current US$) of Andorra and Value added (current US$) of Grenada?
Provide a short and direct response. 1.10e+08. In the year 2008, what is the difference between the Value added (current US$) of Andorra and Value added (current US$) of Guinea?
Provide a succinct answer. -1.45e+08. In the year 2008, what is the difference between the Value added (current US$) in Andorra and Value added (current US$) in Swaziland?
Provide a short and direct response. -8.09e+08. In the year 2008, what is the difference between the Value added (current US$) in Grenada and Value added (current US$) in Guinea?
Keep it short and to the point. -2.55e+08. In the year 2008, what is the difference between the Value added (current US$) of Grenada and Value added (current US$) of Swaziland?
Offer a terse response. -9.19e+08. In the year 2008, what is the difference between the Value added (current US$) of Guinea and Value added (current US$) of Swaziland?
Provide a succinct answer. -6.64e+08. In the year 2009, what is the difference between the Value added (current US$) in Andorra and Value added (current US$) in Grenada?
Keep it short and to the point. 9.57e+07. In the year 2009, what is the difference between the Value added (current US$) in Andorra and Value added (current US$) in Guinea?
Your response must be concise. -1.90e+08. In the year 2009, what is the difference between the Value added (current US$) of Andorra and Value added (current US$) of Swaziland?
Offer a terse response. -8.84e+08. In the year 2009, what is the difference between the Value added (current US$) in Grenada and Value added (current US$) in Guinea?
Make the answer very short. -2.85e+08. In the year 2009, what is the difference between the Value added (current US$) of Grenada and Value added (current US$) of Swaziland?
Give a very brief answer. -9.80e+08. In the year 2009, what is the difference between the Value added (current US$) of Guinea and Value added (current US$) of Swaziland?
Give a very brief answer. -6.95e+08. In the year 2010, what is the difference between the Value added (current US$) in Andorra and Value added (current US$) in Grenada?
Provide a short and direct response. 9.42e+07. In the year 2010, what is the difference between the Value added (current US$) of Andorra and Value added (current US$) of Guinea?
Ensure brevity in your answer.  -1.95e+08. In the year 2010, what is the difference between the Value added (current US$) of Andorra and Value added (current US$) of Swaziland?
Your answer should be compact. -1.16e+09. In the year 2010, what is the difference between the Value added (current US$) of Grenada and Value added (current US$) of Guinea?
Your answer should be compact. -2.89e+08. In the year 2010, what is the difference between the Value added (current US$) of Grenada and Value added (current US$) of Swaziland?
Give a very brief answer. -1.25e+09. In the year 2010, what is the difference between the Value added (current US$) of Guinea and Value added (current US$) of Swaziland?
Keep it short and to the point. -9.65e+08. In the year 2011, what is the difference between the Value added (current US$) in Andorra and Value added (current US$) in Grenada?
Provide a short and direct response. 9.48e+07. In the year 2011, what is the difference between the Value added (current US$) of Andorra and Value added (current US$) of Guinea?
Provide a short and direct response. -2.16e+08. In the year 2011, what is the difference between the Value added (current US$) of Andorra and Value added (current US$) of Swaziland?
Offer a terse response. -1.72e+09. In the year 2011, what is the difference between the Value added (current US$) in Grenada and Value added (current US$) in Guinea?
Give a very brief answer. -3.11e+08. In the year 2011, what is the difference between the Value added (current US$) of Grenada and Value added (current US$) of Swaziland?
Make the answer very short. -1.82e+09. In the year 2011, what is the difference between the Value added (current US$) in Guinea and Value added (current US$) in Swaziland?
Offer a very short reply. -1.51e+09. In the year 2012, what is the difference between the Value added (current US$) of Andorra and Value added (current US$) of Grenada?
Your answer should be compact. 7.74e+07. In the year 2012, what is the difference between the Value added (current US$) of Andorra and Value added (current US$) of Guinea?
Provide a short and direct response. -2.53e+08. In the year 2012, what is the difference between the Value added (current US$) in Andorra and Value added (current US$) in Swaziland?
Provide a short and direct response. -1.66e+09. In the year 2012, what is the difference between the Value added (current US$) in Grenada and Value added (current US$) in Guinea?
Provide a succinct answer. -3.30e+08. In the year 2012, what is the difference between the Value added (current US$) of Grenada and Value added (current US$) of Swaziland?
Your response must be concise. -1.74e+09. In the year 2012, what is the difference between the Value added (current US$) of Guinea and Value added (current US$) of Swaziland?
Keep it short and to the point. -1.41e+09. In the year 2013, what is the difference between the Value added (current US$) of Andorra and Value added (current US$) of Grenada?
Your answer should be compact. 7.43e+07. In the year 2013, what is the difference between the Value added (current US$) in Andorra and Value added (current US$) in Guinea?
Offer a terse response. -2.82e+08. In the year 2013, what is the difference between the Value added (current US$) of Andorra and Value added (current US$) of Swaziland?
Offer a terse response. -1.52e+09. In the year 2013, what is the difference between the Value added (current US$) of Grenada and Value added (current US$) of Guinea?
Your response must be concise. -3.56e+08. In the year 2013, what is the difference between the Value added (current US$) of Grenada and Value added (current US$) of Swaziland?
Provide a succinct answer. -1.59e+09. In the year 2013, what is the difference between the Value added (current US$) of Guinea and Value added (current US$) of Swaziland?
Offer a terse response. -1.24e+09. What is the ratio of the Value added (current US$) of Andorra in 2006 to that in 2007?
Your answer should be compact. 0.89. What is the ratio of the Value added (current US$) of Grenada in 2006 to that in 2007?
Your answer should be very brief. 0.87. What is the ratio of the Value added (current US$) of Guinea in 2006 to that in 2007?
Provide a succinct answer. 0.62. What is the ratio of the Value added (current US$) in Swaziland in 2006 to that in 2007?
Your response must be concise. 0.95. What is the ratio of the Value added (current US$) in Andorra in 2006 to that in 2008?
Offer a very short reply. 0.86. What is the ratio of the Value added (current US$) of Grenada in 2006 to that in 2008?
Keep it short and to the point. 0.86. What is the ratio of the Value added (current US$) of Guinea in 2006 to that in 2008?
Make the answer very short. 0.59. What is the ratio of the Value added (current US$) of Swaziland in 2006 to that in 2008?
Your answer should be compact. 0.95. What is the ratio of the Value added (current US$) in Andorra in 2006 to that in 2009?
Your answer should be compact. 0.97. What is the ratio of the Value added (current US$) of Grenada in 2006 to that in 2009?
Offer a very short reply. 0.92. What is the ratio of the Value added (current US$) of Guinea in 2006 to that in 2009?
Provide a succinct answer. 0.53. What is the ratio of the Value added (current US$) of Swaziland in 2006 to that in 2009?
Provide a short and direct response. 0.89. What is the ratio of the Value added (current US$) in Andorra in 2006 to that in 2010?
Your answer should be compact. 0.97. What is the ratio of the Value added (current US$) in Grenada in 2006 to that in 2010?
Your answer should be compact. 0.89. What is the ratio of the Value added (current US$) of Guinea in 2006 to that in 2010?
Your answer should be very brief. 0.53. What is the ratio of the Value added (current US$) of Swaziland in 2006 to that in 2010?
Offer a very short reply. 0.7. What is the ratio of the Value added (current US$) of Andorra in 2006 to that in 2011?
Your response must be concise. 0.97. What is the ratio of the Value added (current US$) of Grenada in 2006 to that in 2011?
Provide a short and direct response. 0.9. What is the ratio of the Value added (current US$) of Guinea in 2006 to that in 2011?
Ensure brevity in your answer.  0.49. What is the ratio of the Value added (current US$) in Swaziland in 2006 to that in 2011?
Your answer should be very brief. 0.49. What is the ratio of the Value added (current US$) in Andorra in 2006 to that in 2012?
Offer a very short reply. 1.14. What is the ratio of the Value added (current US$) of Grenada in 2006 to that in 2012?
Your answer should be compact. 0.91. What is the ratio of the Value added (current US$) in Guinea in 2006 to that in 2012?
Keep it short and to the point. 0.47. What is the ratio of the Value added (current US$) of Swaziland in 2006 to that in 2012?
Offer a very short reply. 0.51. What is the ratio of the Value added (current US$) in Andorra in 2006 to that in 2013?
Your answer should be compact. 1.14. What is the ratio of the Value added (current US$) in Grenada in 2006 to that in 2013?
Give a very brief answer. 0.83. What is the ratio of the Value added (current US$) in Guinea in 2006 to that in 2013?
Offer a terse response. 0.43. What is the ratio of the Value added (current US$) in Swaziland in 2006 to that in 2013?
Offer a very short reply. 0.55. What is the ratio of the Value added (current US$) of Andorra in 2007 to that in 2008?
Your answer should be very brief. 0.96. What is the ratio of the Value added (current US$) in Guinea in 2007 to that in 2008?
Your answer should be compact. 0.95. What is the ratio of the Value added (current US$) in Andorra in 2007 to that in 2009?
Make the answer very short. 1.09. What is the ratio of the Value added (current US$) of Grenada in 2007 to that in 2009?
Your response must be concise. 1.07. What is the ratio of the Value added (current US$) of Guinea in 2007 to that in 2009?
Make the answer very short. 0.86. What is the ratio of the Value added (current US$) of Swaziland in 2007 to that in 2009?
Make the answer very short. 0.94. What is the ratio of the Value added (current US$) in Andorra in 2007 to that in 2010?
Make the answer very short. 1.09. What is the ratio of the Value added (current US$) of Grenada in 2007 to that in 2010?
Ensure brevity in your answer.  1.02. What is the ratio of the Value added (current US$) of Guinea in 2007 to that in 2010?
Provide a short and direct response. 0.85. What is the ratio of the Value added (current US$) of Swaziland in 2007 to that in 2010?
Give a very brief answer. 0.74. What is the ratio of the Value added (current US$) of Andorra in 2007 to that in 2011?
Offer a terse response. 1.09. What is the ratio of the Value added (current US$) in Grenada in 2007 to that in 2011?
Offer a terse response. 1.04. What is the ratio of the Value added (current US$) in Guinea in 2007 to that in 2011?
Offer a very short reply. 0.79. What is the ratio of the Value added (current US$) of Swaziland in 2007 to that in 2011?
Offer a terse response. 0.51. What is the ratio of the Value added (current US$) of Andorra in 2007 to that in 2012?
Offer a very short reply. 1.28. What is the ratio of the Value added (current US$) of Guinea in 2007 to that in 2012?
Ensure brevity in your answer.  0.75. What is the ratio of the Value added (current US$) in Swaziland in 2007 to that in 2012?
Your response must be concise. 0.54. What is the ratio of the Value added (current US$) of Andorra in 2007 to that in 2013?
Your answer should be very brief. 1.28. What is the ratio of the Value added (current US$) of Grenada in 2007 to that in 2013?
Provide a short and direct response. 0.96. What is the ratio of the Value added (current US$) of Guinea in 2007 to that in 2013?
Ensure brevity in your answer.  0.7. What is the ratio of the Value added (current US$) of Swaziland in 2007 to that in 2013?
Give a very brief answer. 0.58. What is the ratio of the Value added (current US$) of Andorra in 2008 to that in 2009?
Provide a short and direct response. 1.13. What is the ratio of the Value added (current US$) of Grenada in 2008 to that in 2009?
Your answer should be compact. 1.07. What is the ratio of the Value added (current US$) of Guinea in 2008 to that in 2009?
Your answer should be compact. 0.91. What is the ratio of the Value added (current US$) of Swaziland in 2008 to that in 2009?
Your response must be concise. 0.94. What is the ratio of the Value added (current US$) of Andorra in 2008 to that in 2010?
Offer a very short reply. 1.13. What is the ratio of the Value added (current US$) in Grenada in 2008 to that in 2010?
Offer a very short reply. 1.03. What is the ratio of the Value added (current US$) of Guinea in 2008 to that in 2010?
Provide a short and direct response. 0.89. What is the ratio of the Value added (current US$) in Swaziland in 2008 to that in 2010?
Provide a succinct answer. 0.74. What is the ratio of the Value added (current US$) in Andorra in 2008 to that in 2011?
Ensure brevity in your answer.  1.13. What is the ratio of the Value added (current US$) in Grenada in 2008 to that in 2011?
Offer a very short reply. 1.04. What is the ratio of the Value added (current US$) in Guinea in 2008 to that in 2011?
Make the answer very short. 0.84. What is the ratio of the Value added (current US$) in Swaziland in 2008 to that in 2011?
Keep it short and to the point. 0.51. What is the ratio of the Value added (current US$) of Andorra in 2008 to that in 2012?
Your answer should be very brief. 1.32. What is the ratio of the Value added (current US$) in Grenada in 2008 to that in 2012?
Ensure brevity in your answer.  1.05. What is the ratio of the Value added (current US$) of Guinea in 2008 to that in 2012?
Make the answer very short. 0.79. What is the ratio of the Value added (current US$) in Swaziland in 2008 to that in 2012?
Offer a terse response. 0.54. What is the ratio of the Value added (current US$) of Andorra in 2008 to that in 2013?
Provide a short and direct response. 1.33. What is the ratio of the Value added (current US$) of Grenada in 2008 to that in 2013?
Provide a short and direct response. 0.96. What is the ratio of the Value added (current US$) of Guinea in 2008 to that in 2013?
Keep it short and to the point. 0.73. What is the ratio of the Value added (current US$) in Swaziland in 2008 to that in 2013?
Offer a terse response. 0.58. What is the ratio of the Value added (current US$) of Grenada in 2009 to that in 2010?
Make the answer very short. 0.96. What is the ratio of the Value added (current US$) in Guinea in 2009 to that in 2010?
Your answer should be compact. 0.99. What is the ratio of the Value added (current US$) of Swaziland in 2009 to that in 2010?
Keep it short and to the point. 0.79. What is the ratio of the Value added (current US$) in Grenada in 2009 to that in 2011?
Offer a very short reply. 0.97. What is the ratio of the Value added (current US$) in Guinea in 2009 to that in 2011?
Your answer should be very brief. 0.92. What is the ratio of the Value added (current US$) in Swaziland in 2009 to that in 2011?
Make the answer very short. 0.54. What is the ratio of the Value added (current US$) in Andorra in 2009 to that in 2012?
Ensure brevity in your answer.  1.17. What is the ratio of the Value added (current US$) of Grenada in 2009 to that in 2012?
Ensure brevity in your answer.  0.98. What is the ratio of the Value added (current US$) in Guinea in 2009 to that in 2012?
Your answer should be very brief. 0.87. What is the ratio of the Value added (current US$) in Swaziland in 2009 to that in 2012?
Your answer should be very brief. 0.57. What is the ratio of the Value added (current US$) in Andorra in 2009 to that in 2013?
Ensure brevity in your answer.  1.18. What is the ratio of the Value added (current US$) of Grenada in 2009 to that in 2013?
Your response must be concise. 0.9. What is the ratio of the Value added (current US$) in Guinea in 2009 to that in 2013?
Keep it short and to the point. 0.81. What is the ratio of the Value added (current US$) of Swaziland in 2009 to that in 2013?
Provide a succinct answer. 0.62. What is the ratio of the Value added (current US$) of Grenada in 2010 to that in 2011?
Your answer should be very brief. 1.01. What is the ratio of the Value added (current US$) of Guinea in 2010 to that in 2011?
Offer a very short reply. 0.94. What is the ratio of the Value added (current US$) of Swaziland in 2010 to that in 2011?
Offer a very short reply. 0.69. What is the ratio of the Value added (current US$) in Andorra in 2010 to that in 2012?
Provide a succinct answer. 1.17. What is the ratio of the Value added (current US$) in Grenada in 2010 to that in 2012?
Ensure brevity in your answer.  1.03. What is the ratio of the Value added (current US$) in Guinea in 2010 to that in 2012?
Your answer should be very brief. 0.89. What is the ratio of the Value added (current US$) of Swaziland in 2010 to that in 2012?
Keep it short and to the point. 0.72. What is the ratio of the Value added (current US$) in Andorra in 2010 to that in 2013?
Offer a terse response. 1.18. What is the ratio of the Value added (current US$) of Grenada in 2010 to that in 2013?
Provide a short and direct response. 0.93. What is the ratio of the Value added (current US$) of Guinea in 2010 to that in 2013?
Your answer should be very brief. 0.82. What is the ratio of the Value added (current US$) in Swaziland in 2010 to that in 2013?
Ensure brevity in your answer.  0.79. What is the ratio of the Value added (current US$) of Andorra in 2011 to that in 2012?
Your answer should be compact. 1.17. What is the ratio of the Value added (current US$) of Grenada in 2011 to that in 2012?
Ensure brevity in your answer.  1.01. What is the ratio of the Value added (current US$) in Guinea in 2011 to that in 2012?
Give a very brief answer. 0.95. What is the ratio of the Value added (current US$) of Swaziland in 2011 to that in 2012?
Offer a terse response. 1.04. What is the ratio of the Value added (current US$) of Andorra in 2011 to that in 2013?
Your answer should be very brief. 1.18. What is the ratio of the Value added (current US$) of Grenada in 2011 to that in 2013?
Offer a very short reply. 0.92. What is the ratio of the Value added (current US$) of Guinea in 2011 to that in 2013?
Your answer should be very brief. 0.88. What is the ratio of the Value added (current US$) in Swaziland in 2011 to that in 2013?
Provide a succinct answer. 1.14. What is the ratio of the Value added (current US$) in Andorra in 2012 to that in 2013?
Make the answer very short. 1.01. What is the ratio of the Value added (current US$) in Grenada in 2012 to that in 2013?
Ensure brevity in your answer.  0.91. What is the ratio of the Value added (current US$) in Guinea in 2012 to that in 2013?
Keep it short and to the point. 0.93. What is the ratio of the Value added (current US$) in Swaziland in 2012 to that in 2013?
Keep it short and to the point. 1.09. What is the difference between the highest and the second highest Value added (current US$) in Andorra?
Provide a short and direct response. 4.90e+06. What is the difference between the highest and the second highest Value added (current US$) in Grenada?
Your response must be concise. 1.12e+06. What is the difference between the highest and the second highest Value added (current US$) in Guinea?
Offer a terse response. 2.83e+07. What is the difference between the highest and the second highest Value added (current US$) of Swaziland?
Ensure brevity in your answer.  7.75e+07. What is the difference between the highest and the lowest Value added (current US$) in Andorra?
Ensure brevity in your answer.  3.42e+07. What is the difference between the highest and the lowest Value added (current US$) in Grenada?
Keep it short and to the point. 4.85e+06. What is the difference between the highest and the lowest Value added (current US$) of Guinea?
Keep it short and to the point. 2.19e+08. What is the difference between the highest and the lowest Value added (current US$) of Swaziland?
Offer a terse response. 9.47e+08. 